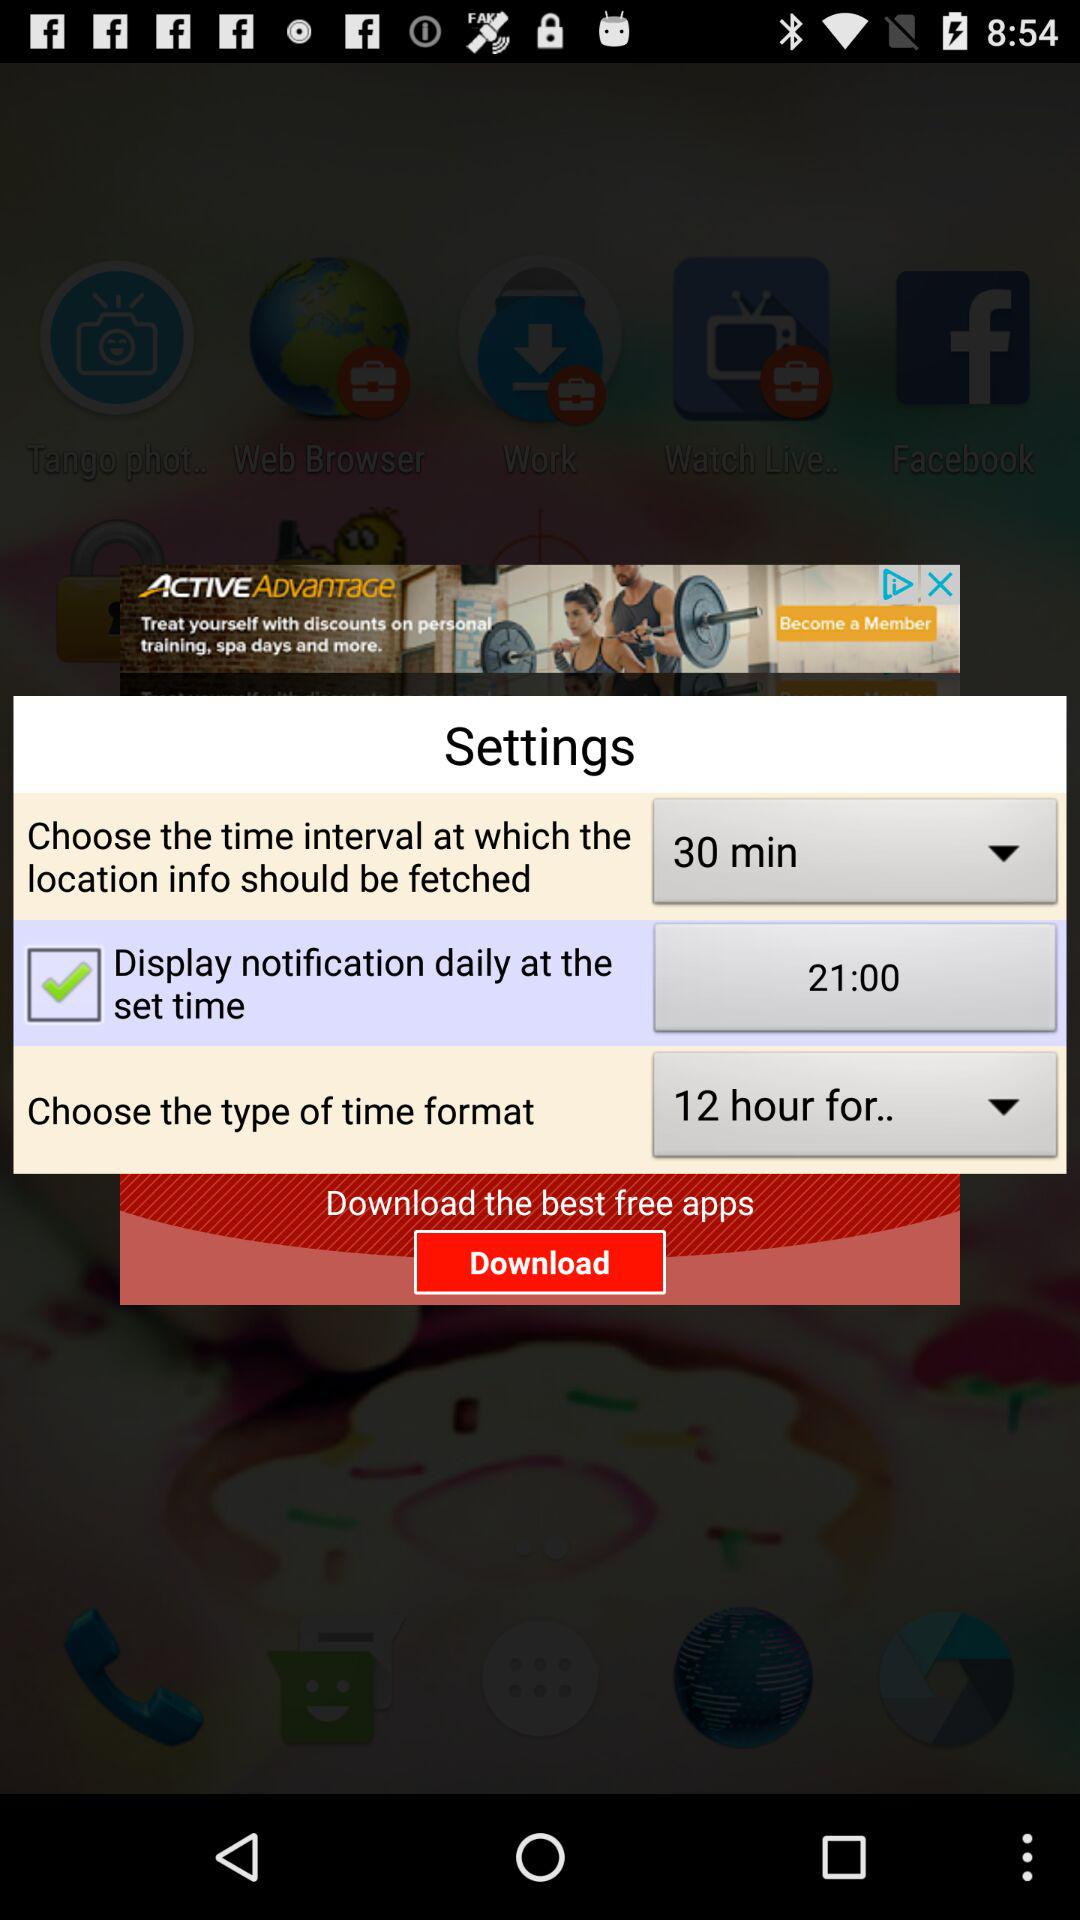What is the set time for the display notification daily? The set time is 21:00. 